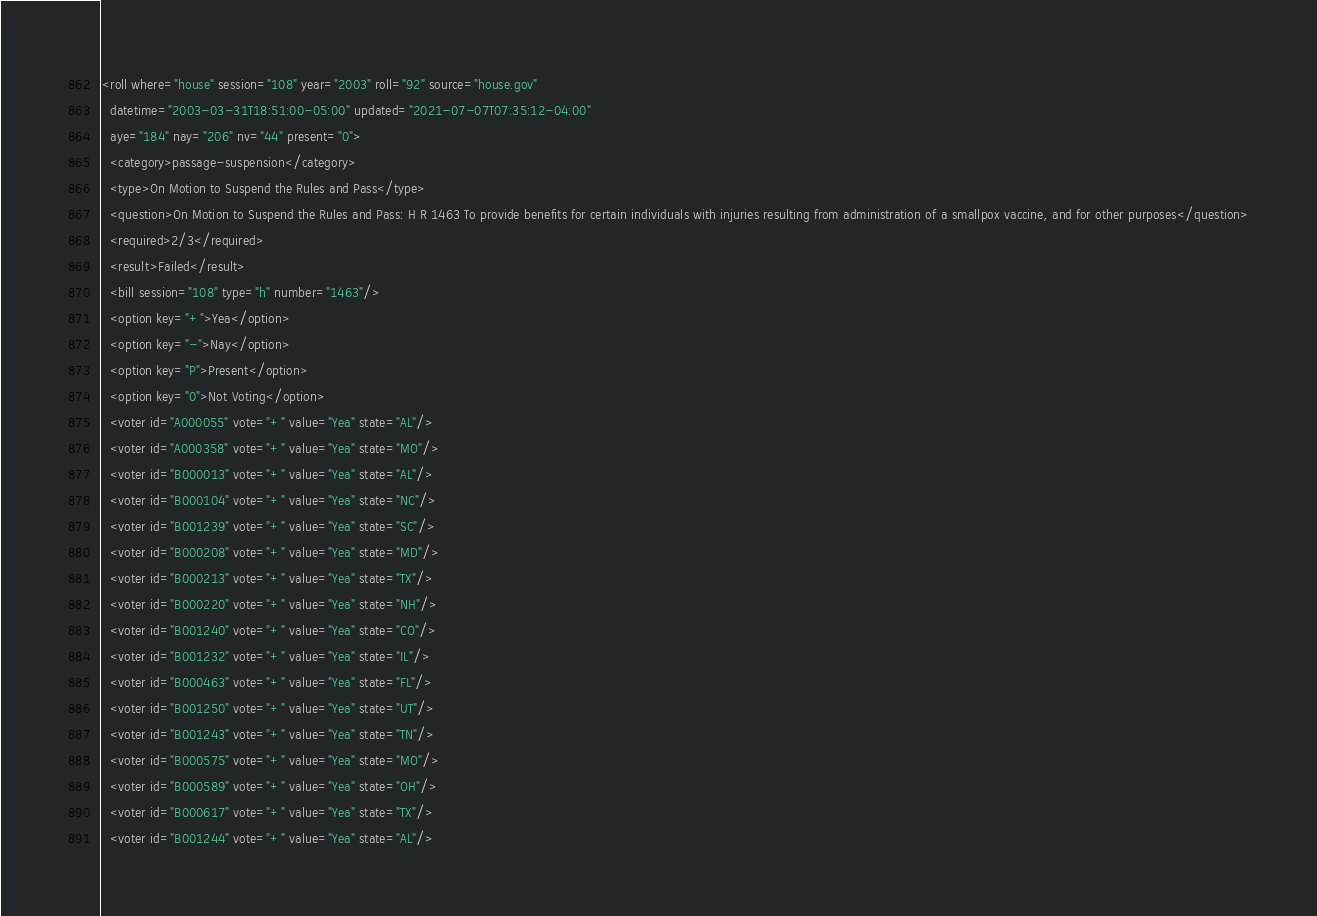Convert code to text. <code><loc_0><loc_0><loc_500><loc_500><_XML_><roll where="house" session="108" year="2003" roll="92" source="house.gov"
  datetime="2003-03-31T18:51:00-05:00" updated="2021-07-07T07:35:12-04:00"
  aye="184" nay="206" nv="44" present="0">
  <category>passage-suspension</category>
  <type>On Motion to Suspend the Rules and Pass</type>
  <question>On Motion to Suspend the Rules and Pass: H R 1463 To provide benefits for certain individuals with injuries resulting from administration of a smallpox vaccine, and for other purposes</question>
  <required>2/3</required>
  <result>Failed</result>
  <bill session="108" type="h" number="1463"/>
  <option key="+">Yea</option>
  <option key="-">Nay</option>
  <option key="P">Present</option>
  <option key="0">Not Voting</option>
  <voter id="A000055" vote="+" value="Yea" state="AL"/>
  <voter id="A000358" vote="+" value="Yea" state="MO"/>
  <voter id="B000013" vote="+" value="Yea" state="AL"/>
  <voter id="B000104" vote="+" value="Yea" state="NC"/>
  <voter id="B001239" vote="+" value="Yea" state="SC"/>
  <voter id="B000208" vote="+" value="Yea" state="MD"/>
  <voter id="B000213" vote="+" value="Yea" state="TX"/>
  <voter id="B000220" vote="+" value="Yea" state="NH"/>
  <voter id="B001240" vote="+" value="Yea" state="CO"/>
  <voter id="B001232" vote="+" value="Yea" state="IL"/>
  <voter id="B000463" vote="+" value="Yea" state="FL"/>
  <voter id="B001250" vote="+" value="Yea" state="UT"/>
  <voter id="B001243" vote="+" value="Yea" state="TN"/>
  <voter id="B000575" vote="+" value="Yea" state="MO"/>
  <voter id="B000589" vote="+" value="Yea" state="OH"/>
  <voter id="B000617" vote="+" value="Yea" state="TX"/>
  <voter id="B001244" vote="+" value="Yea" state="AL"/></code> 